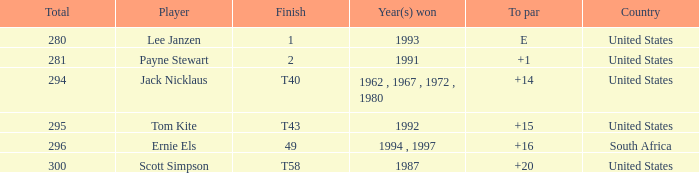What is the Total of the Player with a Finish of 1? 1.0. 